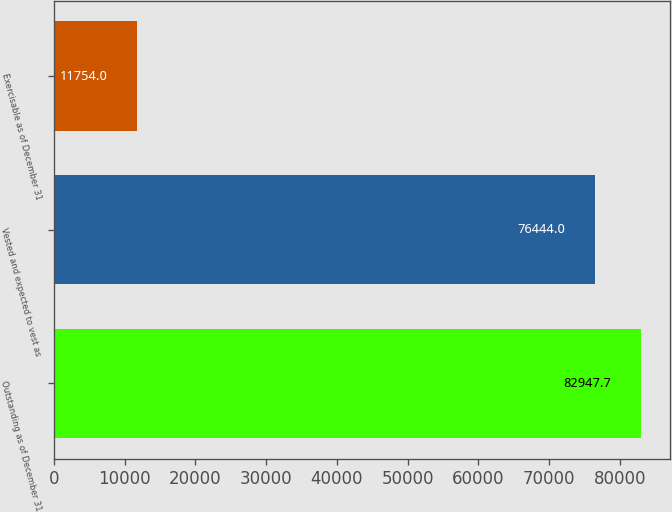<chart> <loc_0><loc_0><loc_500><loc_500><bar_chart><fcel>Outstanding as of December 31<fcel>Vested and expected to vest as<fcel>Exercisable as of December 31<nl><fcel>82947.7<fcel>76444<fcel>11754<nl></chart> 